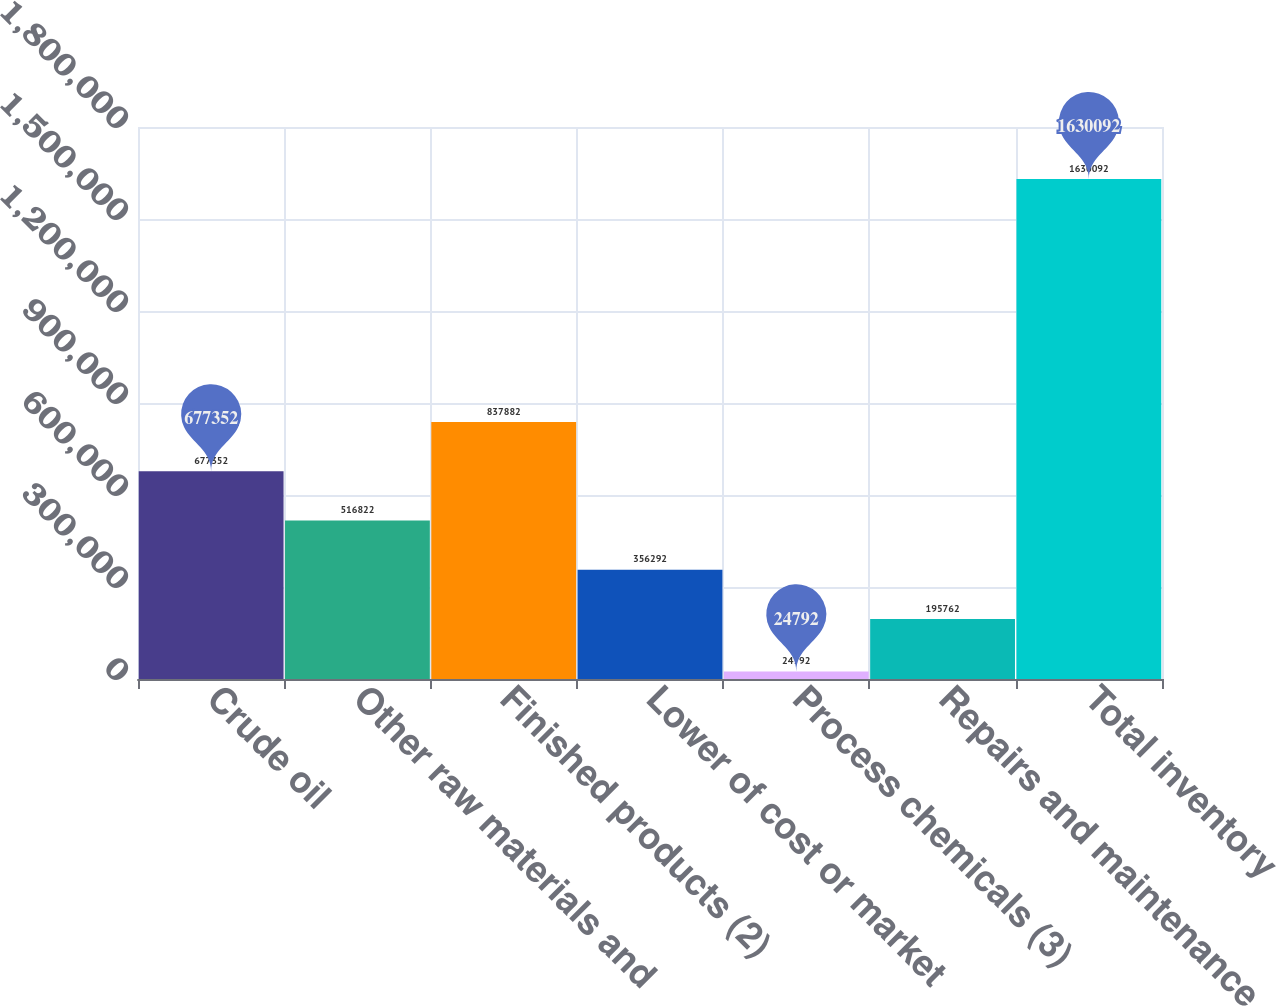Convert chart to OTSL. <chart><loc_0><loc_0><loc_500><loc_500><bar_chart><fcel>Crude oil<fcel>Other raw materials and<fcel>Finished products (2)<fcel>Lower of cost or market<fcel>Process chemicals (3)<fcel>Repairs and maintenance<fcel>Total inventory<nl><fcel>677352<fcel>516822<fcel>837882<fcel>356292<fcel>24792<fcel>195762<fcel>1.63009e+06<nl></chart> 